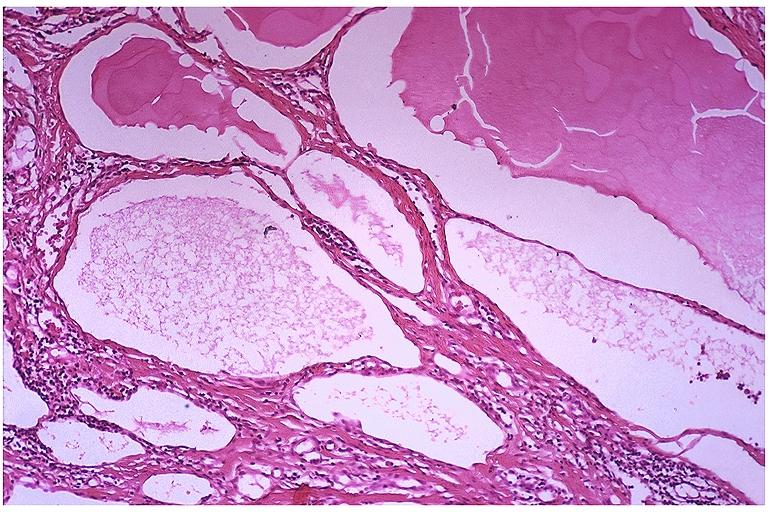what does this image show?
Answer the question using a single word or phrase. Lymphangioma 